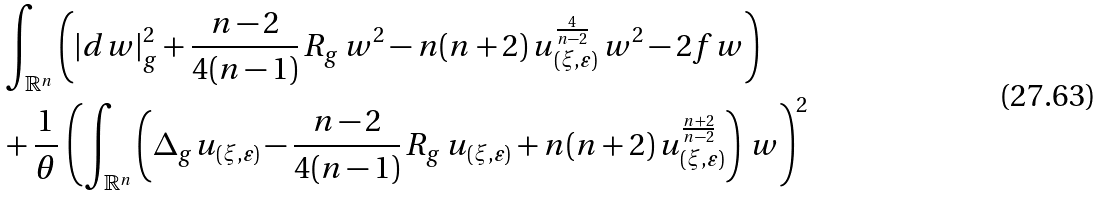<formula> <loc_0><loc_0><loc_500><loc_500>& \int _ { \mathbb { R } ^ { n } } \left ( | d w | _ { g } ^ { 2 } + \frac { n - 2 } { 4 ( n - 1 ) } \, R _ { g } \, w ^ { 2 } - n ( n + 2 ) \, u _ { ( \xi , \varepsilon ) } ^ { \frac { 4 } { n - 2 } } \, w ^ { 2 } - 2 f w \right ) \\ & + \frac { 1 } { \theta } \, \left ( \int _ { \mathbb { R } ^ { n } } \left ( \Delta _ { g } u _ { ( \xi , \varepsilon ) } - \frac { n - 2 } { 4 ( n - 1 ) } \, R _ { g } \, u _ { ( \xi , \varepsilon ) } + n ( n + 2 ) \, u _ { ( \xi , \varepsilon ) } ^ { \frac { n + 2 } { n - 2 } } \right ) \, w \right ) ^ { 2 }</formula> 